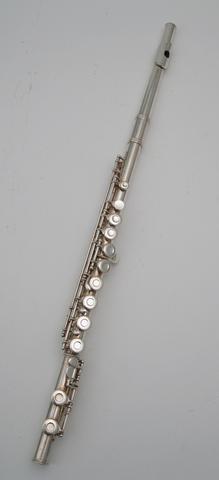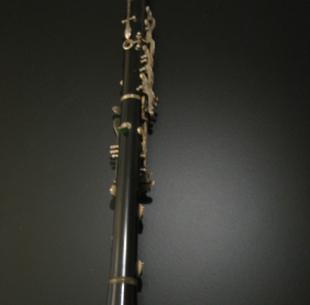The first image is the image on the left, the second image is the image on the right. Considering the images on both sides, is "The instrument on the left is silver and is displayed at an angle, while the instrument on the right is a dark color and is displayed more vertically." valid? Answer yes or no. Yes. The first image is the image on the left, the second image is the image on the right. Given the left and right images, does the statement "One of the instruments is completely silver colored." hold true? Answer yes or no. Yes. 